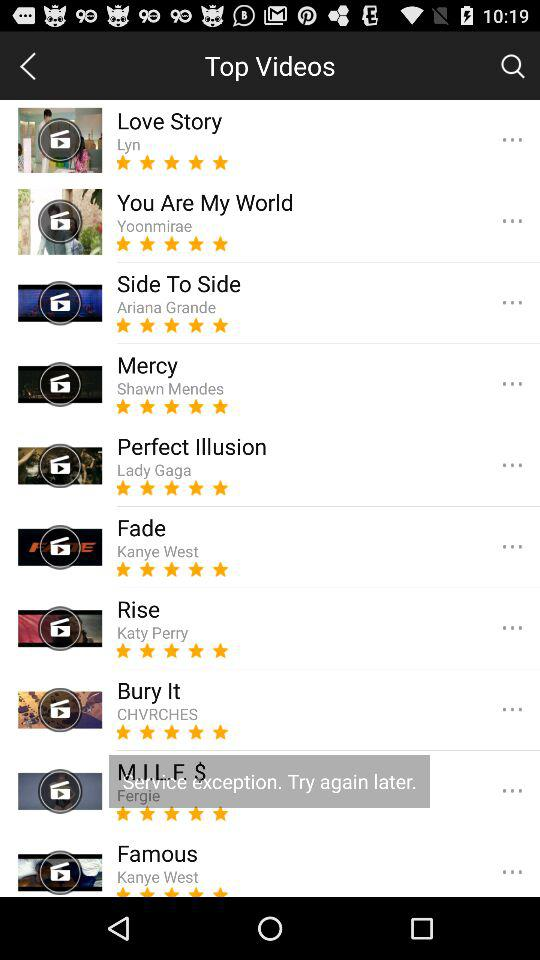How many videos are on the Top Videos page?
Answer the question using a single word or phrase. 10 